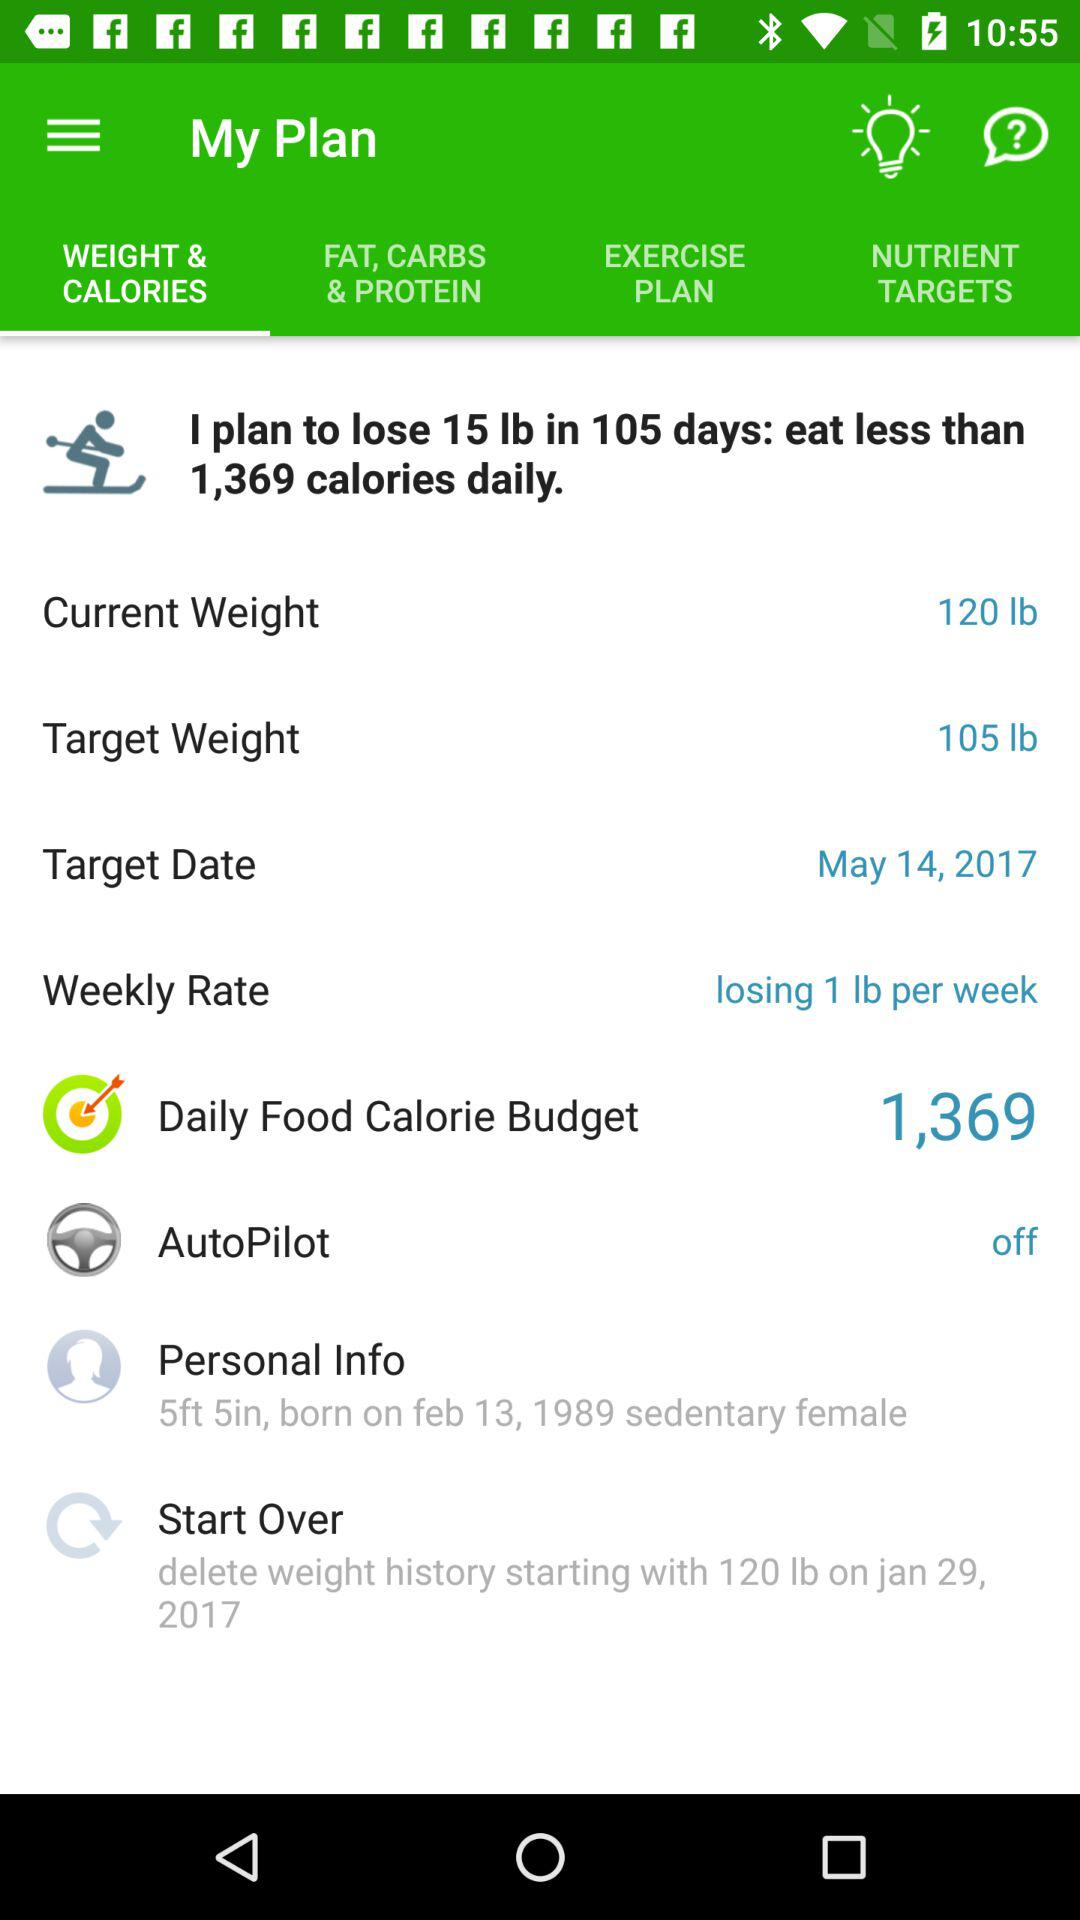What is the target date? The target date is May 14, 2017. 